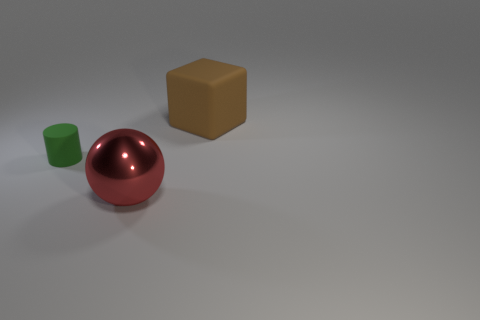What could be the context or setting for these objects? The context is minimalistic and abstract, potentially representing a simple 3D modeling or rendering exercise. The objects are placed on a flat surface with a faint shadow, suggesting a controlled environment with a single light source. Could this setting be used in a specific industry or field? Indeed, such a setting might be used in various industries, including graphic design, education for teaching shape recognition, advertising to showcase product design, or even in gaming as preliminary asset design. 